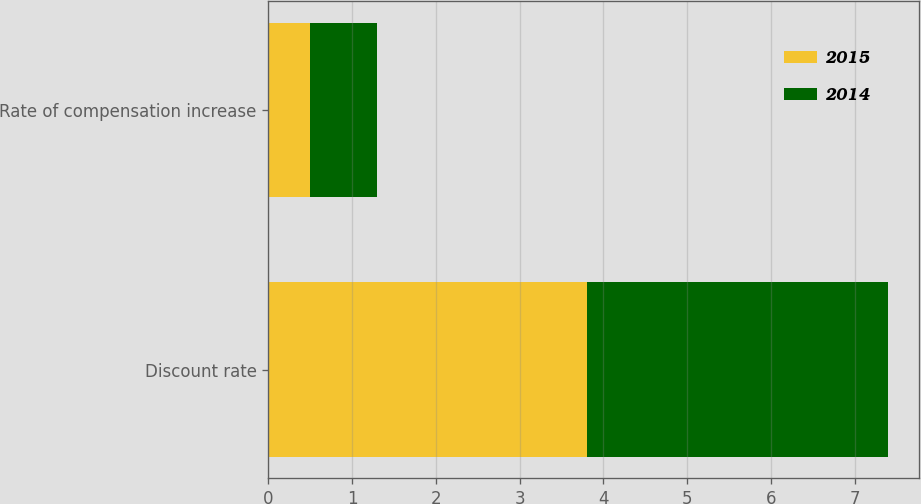Convert chart. <chart><loc_0><loc_0><loc_500><loc_500><stacked_bar_chart><ecel><fcel>Discount rate<fcel>Rate of compensation increase<nl><fcel>2015<fcel>3.8<fcel>0.5<nl><fcel>2014<fcel>3.6<fcel>0.8<nl></chart> 